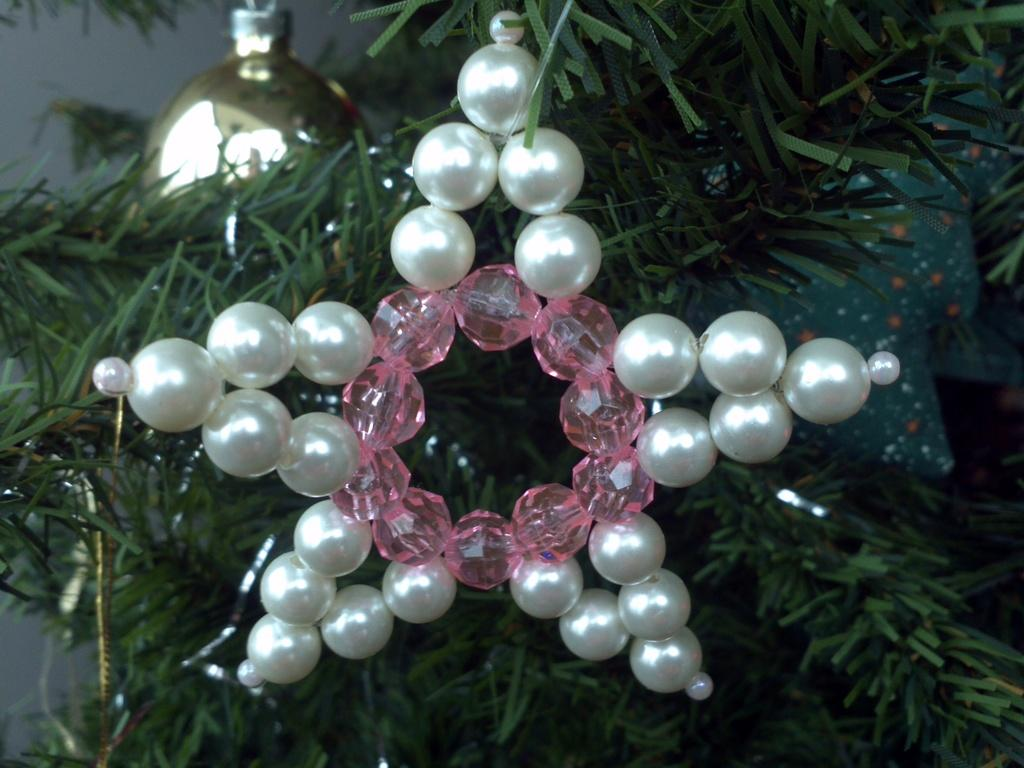What is the main subject of the image? There is a Christmas tree in the image. How is the Christmas tree decorated? The Christmas tree is decorated with pearls. What type of honey can be seen dripping from the crow in the image? There is no crow or honey present in the image; it features a Christmas tree decorated with pearls. 